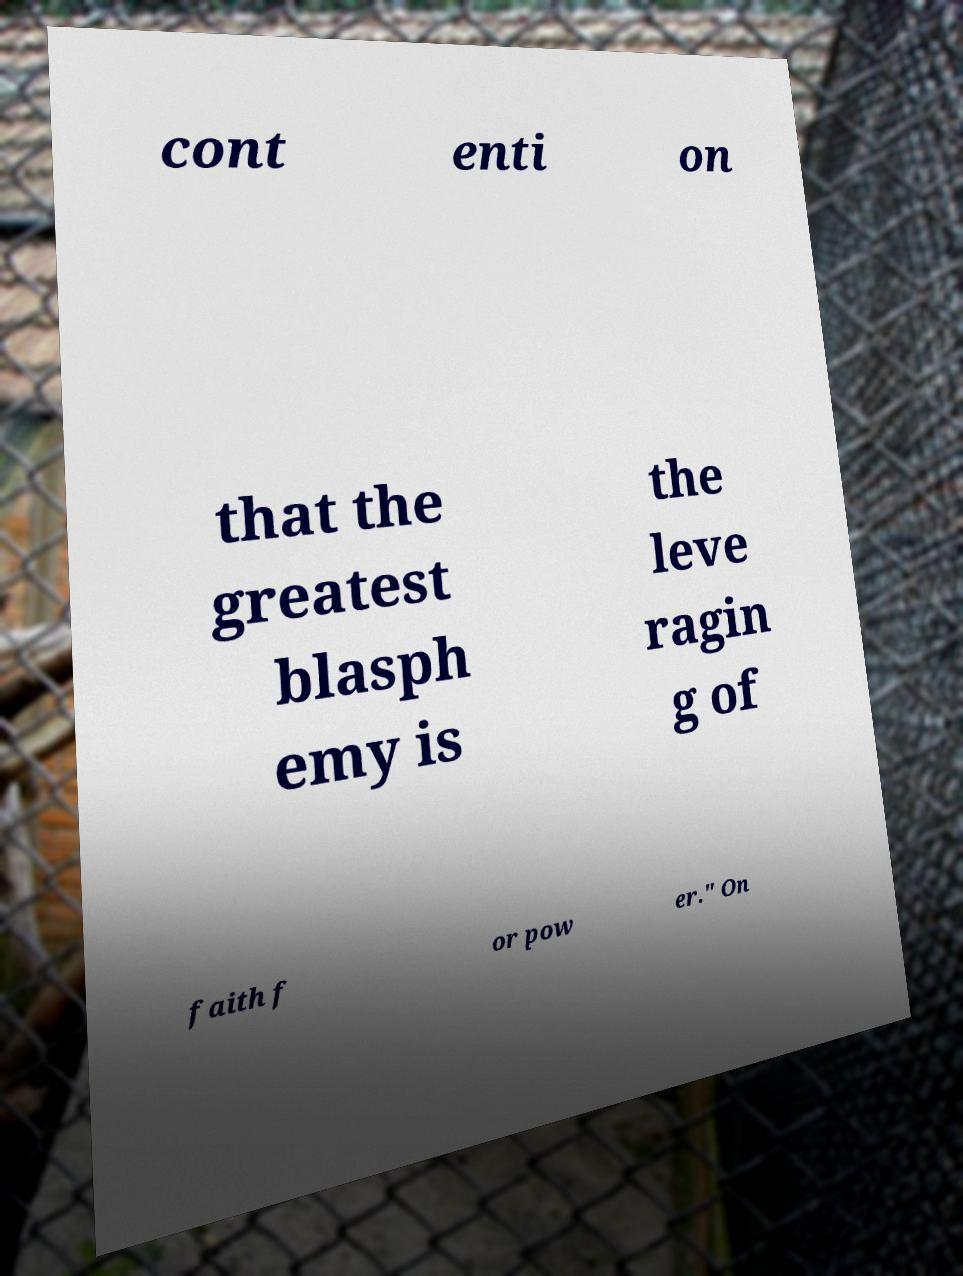There's text embedded in this image that I need extracted. Can you transcribe it verbatim? cont enti on that the greatest blasph emy is the leve ragin g of faith f or pow er." On 